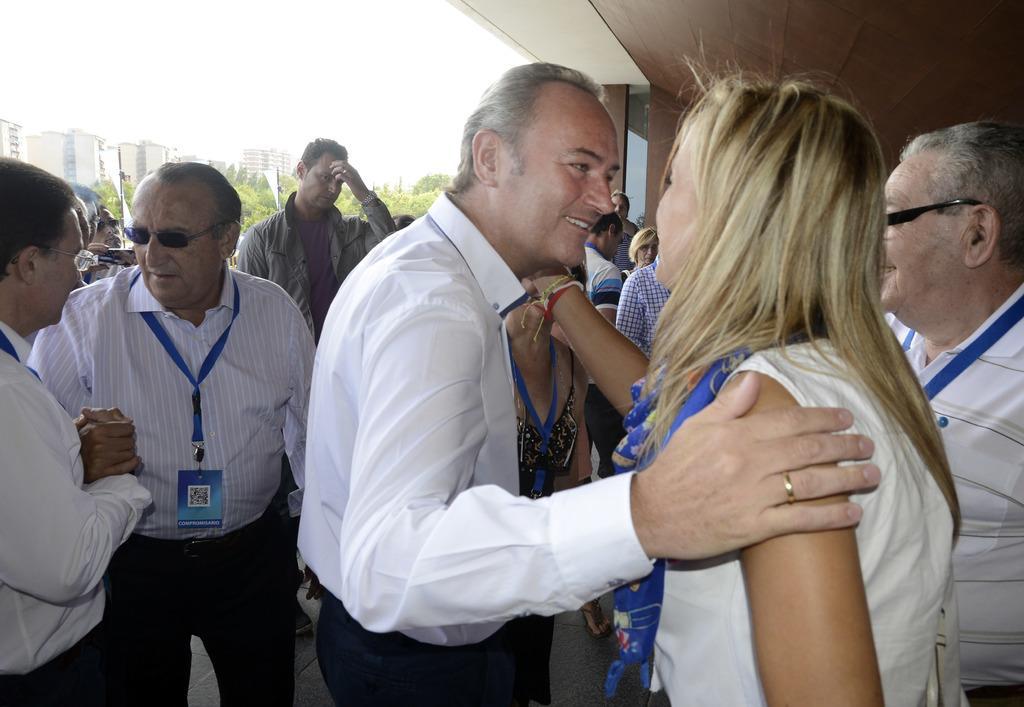Could you give a brief overview of what you see in this image? In this picture I can see a group of person standing. Behind the person I can see group of trees and building. At the top I can see the sky and a roof. 